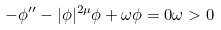Convert formula to latex. <formula><loc_0><loc_0><loc_500><loc_500>- \phi ^ { \prime \prime } - | \phi | ^ { 2 \mu } \phi + \omega \phi = 0 \omega > 0</formula> 